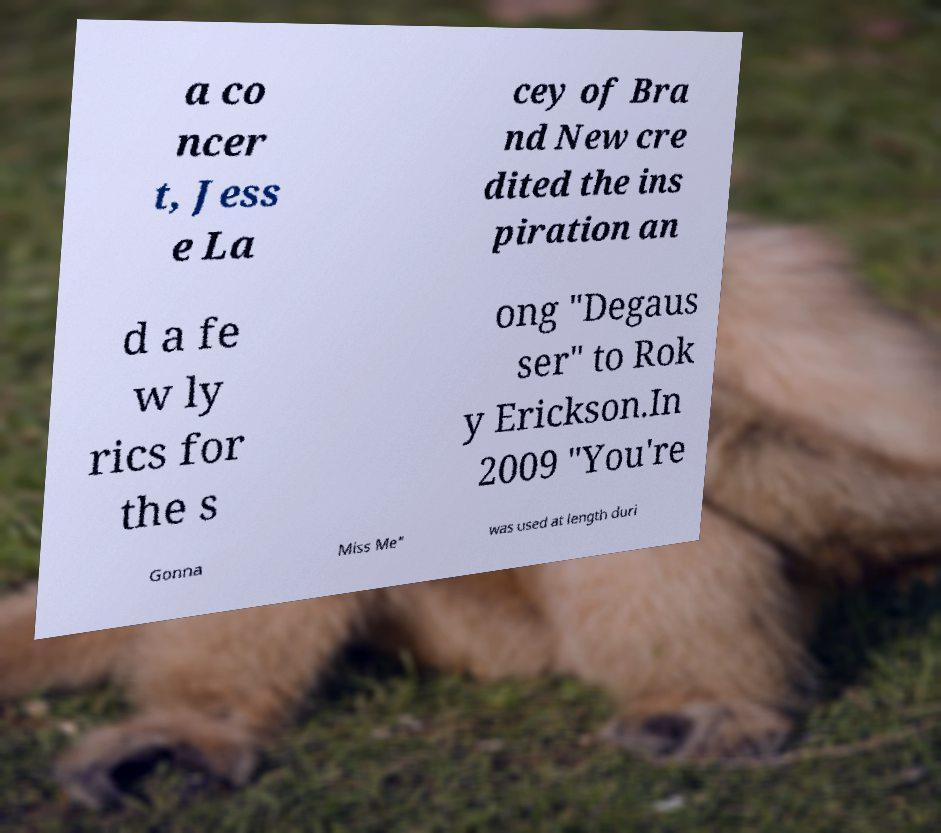I need the written content from this picture converted into text. Can you do that? a co ncer t, Jess e La cey of Bra nd New cre dited the ins piration an d a fe w ly rics for the s ong "Degaus ser" to Rok y Erickson.In 2009 "You're Gonna Miss Me" was used at length duri 